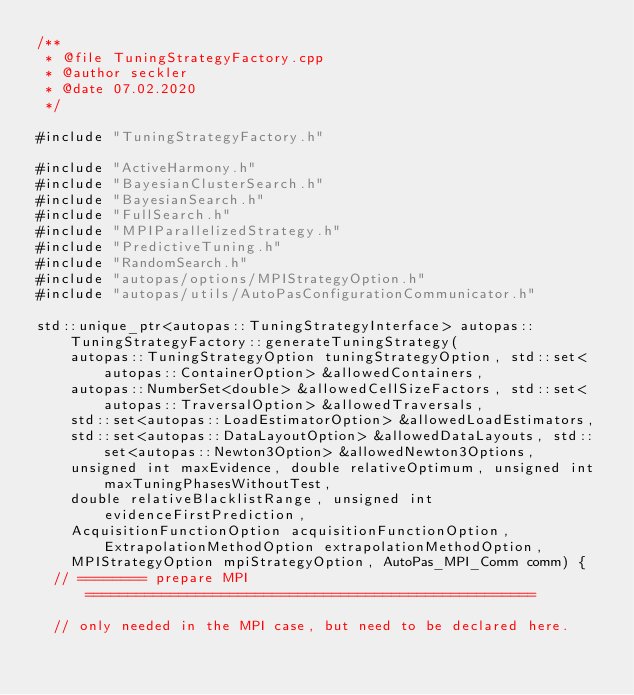<code> <loc_0><loc_0><loc_500><loc_500><_C++_>/**
 * @file TuningStrategyFactory.cpp
 * @author seckler
 * @date 07.02.2020
 */

#include "TuningStrategyFactory.h"

#include "ActiveHarmony.h"
#include "BayesianClusterSearch.h"
#include "BayesianSearch.h"
#include "FullSearch.h"
#include "MPIParallelizedStrategy.h"
#include "PredictiveTuning.h"
#include "RandomSearch.h"
#include "autopas/options/MPIStrategyOption.h"
#include "autopas/utils/AutoPasConfigurationCommunicator.h"

std::unique_ptr<autopas::TuningStrategyInterface> autopas::TuningStrategyFactory::generateTuningStrategy(
    autopas::TuningStrategyOption tuningStrategyOption, std::set<autopas::ContainerOption> &allowedContainers,
    autopas::NumberSet<double> &allowedCellSizeFactors, std::set<autopas::TraversalOption> &allowedTraversals,
    std::set<autopas::LoadEstimatorOption> &allowedLoadEstimators,
    std::set<autopas::DataLayoutOption> &allowedDataLayouts, std::set<autopas::Newton3Option> &allowedNewton3Options,
    unsigned int maxEvidence, double relativeOptimum, unsigned int maxTuningPhasesWithoutTest,
    double relativeBlacklistRange, unsigned int evidenceFirstPrediction,
    AcquisitionFunctionOption acquisitionFunctionOption, ExtrapolationMethodOption extrapolationMethodOption,
    MPIStrategyOption mpiStrategyOption, AutoPas_MPI_Comm comm) {
  // ======== prepare MPI =====================================================

  // only needed in the MPI case, but need to be declared here.</code> 